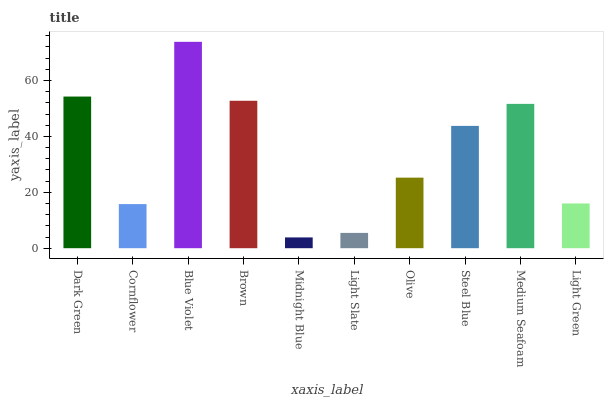Is Midnight Blue the minimum?
Answer yes or no. Yes. Is Blue Violet the maximum?
Answer yes or no. Yes. Is Cornflower the minimum?
Answer yes or no. No. Is Cornflower the maximum?
Answer yes or no. No. Is Dark Green greater than Cornflower?
Answer yes or no. Yes. Is Cornflower less than Dark Green?
Answer yes or no. Yes. Is Cornflower greater than Dark Green?
Answer yes or no. No. Is Dark Green less than Cornflower?
Answer yes or no. No. Is Steel Blue the high median?
Answer yes or no. Yes. Is Olive the low median?
Answer yes or no. Yes. Is Cornflower the high median?
Answer yes or no. No. Is Medium Seafoam the low median?
Answer yes or no. No. 